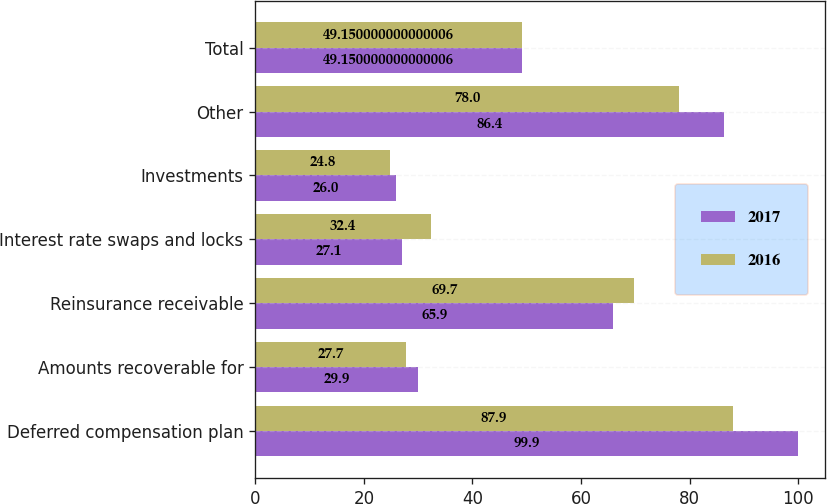Convert chart to OTSL. <chart><loc_0><loc_0><loc_500><loc_500><stacked_bar_chart><ecel><fcel>Deferred compensation plan<fcel>Amounts recoverable for<fcel>Reinsurance receivable<fcel>Interest rate swaps and locks<fcel>Investments<fcel>Other<fcel>Total<nl><fcel>2017<fcel>99.9<fcel>29.9<fcel>65.9<fcel>27.1<fcel>26<fcel>86.4<fcel>49.15<nl><fcel>2016<fcel>87.9<fcel>27.7<fcel>69.7<fcel>32.4<fcel>24.8<fcel>78<fcel>49.15<nl></chart> 